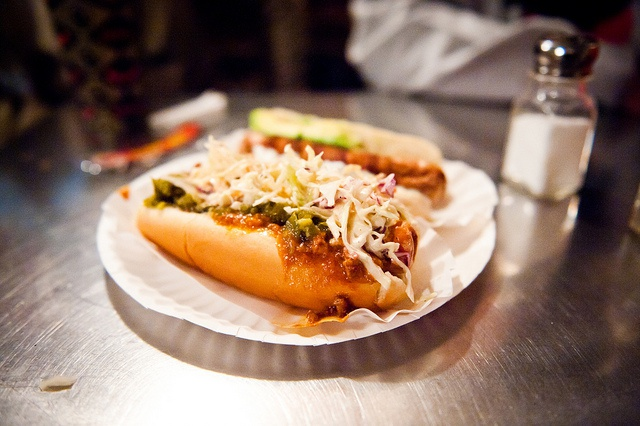Describe the objects in this image and their specific colors. I can see dining table in black, white, maroon, and gray tones, hot dog in black, tan, ivory, red, and orange tones, bottle in black, lightgray, and tan tones, and hot dog in black, red, brown, maroon, and orange tones in this image. 